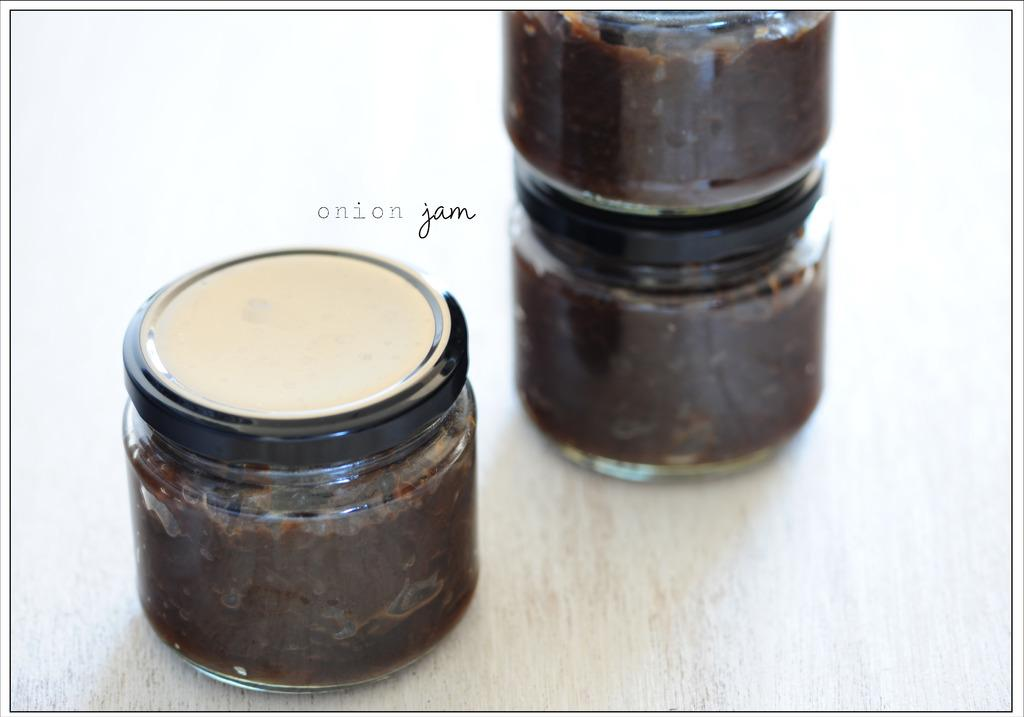<image>
Render a clear and concise summary of the photo. A photograph of jars features the text "onion jam." 